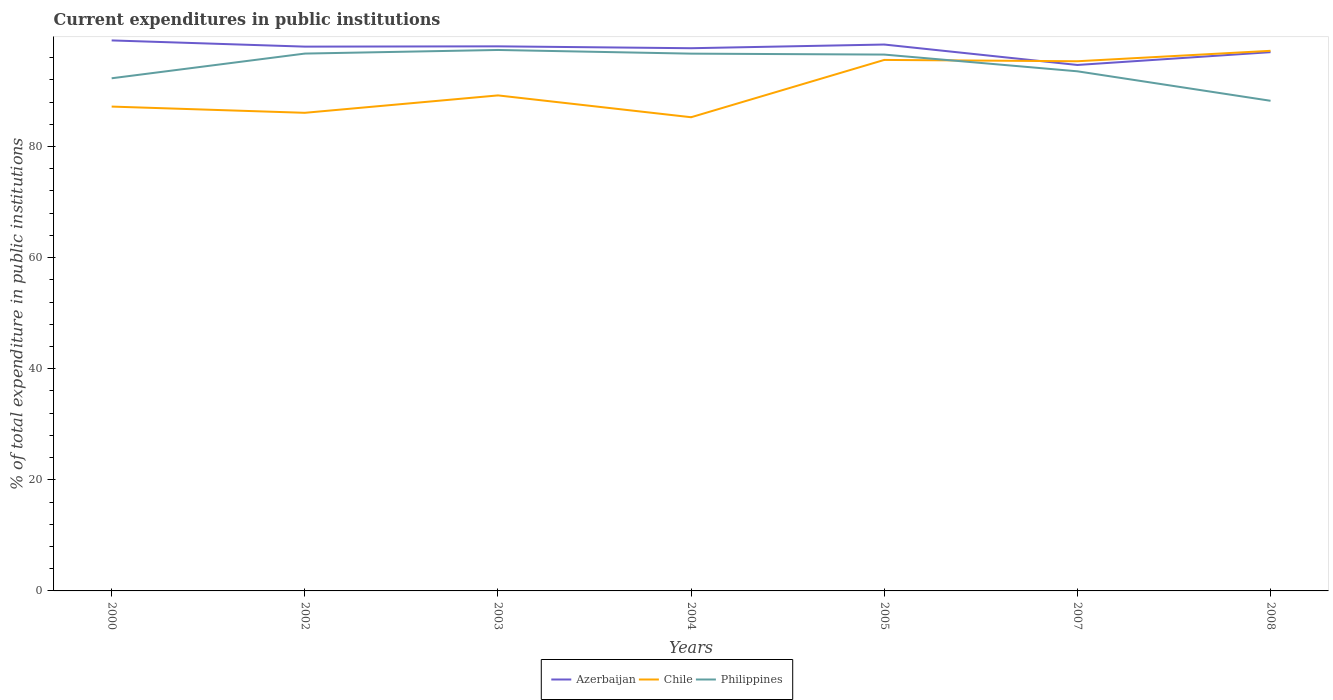Is the number of lines equal to the number of legend labels?
Provide a short and direct response. Yes. Across all years, what is the maximum current expenditures in public institutions in Philippines?
Keep it short and to the point. 88.23. In which year was the current expenditures in public institutions in Azerbaijan maximum?
Give a very brief answer. 2007. What is the total current expenditures in public institutions in Azerbaijan in the graph?
Keep it short and to the point. 1.41. What is the difference between the highest and the second highest current expenditures in public institutions in Azerbaijan?
Offer a very short reply. 4.42. Is the current expenditures in public institutions in Azerbaijan strictly greater than the current expenditures in public institutions in Chile over the years?
Your answer should be very brief. No. How many lines are there?
Keep it short and to the point. 3. What is the difference between two consecutive major ticks on the Y-axis?
Provide a succinct answer. 20. Are the values on the major ticks of Y-axis written in scientific E-notation?
Ensure brevity in your answer.  No. Does the graph contain grids?
Offer a terse response. No. Where does the legend appear in the graph?
Provide a short and direct response. Bottom center. How are the legend labels stacked?
Offer a very short reply. Horizontal. What is the title of the graph?
Your response must be concise. Current expenditures in public institutions. What is the label or title of the Y-axis?
Your response must be concise. % of total expenditure in public institutions. What is the % of total expenditure in public institutions in Azerbaijan in 2000?
Provide a short and direct response. 99.1. What is the % of total expenditure in public institutions of Chile in 2000?
Ensure brevity in your answer.  87.19. What is the % of total expenditure in public institutions of Philippines in 2000?
Provide a short and direct response. 92.28. What is the % of total expenditure in public institutions of Azerbaijan in 2002?
Offer a very short reply. 97.98. What is the % of total expenditure in public institutions in Chile in 2002?
Keep it short and to the point. 86.07. What is the % of total expenditure in public institutions in Philippines in 2002?
Offer a terse response. 96.73. What is the % of total expenditure in public institutions of Azerbaijan in 2003?
Provide a short and direct response. 98.03. What is the % of total expenditure in public institutions of Chile in 2003?
Give a very brief answer. 89.2. What is the % of total expenditure in public institutions of Philippines in 2003?
Your answer should be compact. 97.38. What is the % of total expenditure in public institutions of Azerbaijan in 2004?
Make the answer very short. 97.7. What is the % of total expenditure in public institutions in Chile in 2004?
Provide a short and direct response. 85.27. What is the % of total expenditure in public institutions of Philippines in 2004?
Provide a short and direct response. 96.72. What is the % of total expenditure in public institutions in Azerbaijan in 2005?
Ensure brevity in your answer.  98.36. What is the % of total expenditure in public institutions of Chile in 2005?
Give a very brief answer. 95.59. What is the % of total expenditure in public institutions in Philippines in 2005?
Offer a very short reply. 96.55. What is the % of total expenditure in public institutions in Azerbaijan in 2007?
Your response must be concise. 94.68. What is the % of total expenditure in public institutions of Chile in 2007?
Provide a succinct answer. 95.35. What is the % of total expenditure in public institutions of Philippines in 2007?
Provide a succinct answer. 93.54. What is the % of total expenditure in public institutions in Azerbaijan in 2008?
Offer a very short reply. 96.99. What is the % of total expenditure in public institutions in Chile in 2008?
Provide a succinct answer. 97.23. What is the % of total expenditure in public institutions in Philippines in 2008?
Your answer should be very brief. 88.23. Across all years, what is the maximum % of total expenditure in public institutions in Azerbaijan?
Give a very brief answer. 99.1. Across all years, what is the maximum % of total expenditure in public institutions of Chile?
Your answer should be compact. 97.23. Across all years, what is the maximum % of total expenditure in public institutions of Philippines?
Keep it short and to the point. 97.38. Across all years, what is the minimum % of total expenditure in public institutions of Azerbaijan?
Make the answer very short. 94.68. Across all years, what is the minimum % of total expenditure in public institutions in Chile?
Your answer should be very brief. 85.27. Across all years, what is the minimum % of total expenditure in public institutions of Philippines?
Your answer should be very brief. 88.23. What is the total % of total expenditure in public institutions of Azerbaijan in the graph?
Offer a terse response. 682.84. What is the total % of total expenditure in public institutions of Chile in the graph?
Provide a short and direct response. 635.9. What is the total % of total expenditure in public institutions of Philippines in the graph?
Provide a succinct answer. 661.44. What is the difference between the % of total expenditure in public institutions in Azerbaijan in 2000 and that in 2002?
Your answer should be very brief. 1.12. What is the difference between the % of total expenditure in public institutions of Chile in 2000 and that in 2002?
Your answer should be very brief. 1.12. What is the difference between the % of total expenditure in public institutions of Philippines in 2000 and that in 2002?
Your answer should be very brief. -4.45. What is the difference between the % of total expenditure in public institutions in Azerbaijan in 2000 and that in 2003?
Offer a terse response. 1.07. What is the difference between the % of total expenditure in public institutions of Chile in 2000 and that in 2003?
Your answer should be compact. -2.01. What is the difference between the % of total expenditure in public institutions in Philippines in 2000 and that in 2003?
Provide a succinct answer. -5.1. What is the difference between the % of total expenditure in public institutions in Azerbaijan in 2000 and that in 2004?
Provide a short and direct response. 1.41. What is the difference between the % of total expenditure in public institutions of Chile in 2000 and that in 2004?
Offer a terse response. 1.92. What is the difference between the % of total expenditure in public institutions in Philippines in 2000 and that in 2004?
Ensure brevity in your answer.  -4.44. What is the difference between the % of total expenditure in public institutions of Azerbaijan in 2000 and that in 2005?
Provide a short and direct response. 0.74. What is the difference between the % of total expenditure in public institutions in Chile in 2000 and that in 2005?
Your answer should be compact. -8.4. What is the difference between the % of total expenditure in public institutions in Philippines in 2000 and that in 2005?
Provide a succinct answer. -4.27. What is the difference between the % of total expenditure in public institutions in Azerbaijan in 2000 and that in 2007?
Provide a succinct answer. 4.42. What is the difference between the % of total expenditure in public institutions in Chile in 2000 and that in 2007?
Your answer should be very brief. -8.16. What is the difference between the % of total expenditure in public institutions of Philippines in 2000 and that in 2007?
Ensure brevity in your answer.  -1.26. What is the difference between the % of total expenditure in public institutions of Azerbaijan in 2000 and that in 2008?
Provide a succinct answer. 2.11. What is the difference between the % of total expenditure in public institutions of Chile in 2000 and that in 2008?
Your answer should be compact. -10.04. What is the difference between the % of total expenditure in public institutions in Philippines in 2000 and that in 2008?
Offer a terse response. 4.05. What is the difference between the % of total expenditure in public institutions of Azerbaijan in 2002 and that in 2003?
Your answer should be compact. -0.05. What is the difference between the % of total expenditure in public institutions in Chile in 2002 and that in 2003?
Give a very brief answer. -3.13. What is the difference between the % of total expenditure in public institutions of Philippines in 2002 and that in 2003?
Ensure brevity in your answer.  -0.65. What is the difference between the % of total expenditure in public institutions of Azerbaijan in 2002 and that in 2004?
Your answer should be compact. 0.29. What is the difference between the % of total expenditure in public institutions in Chile in 2002 and that in 2004?
Keep it short and to the point. 0.8. What is the difference between the % of total expenditure in public institutions in Philippines in 2002 and that in 2004?
Provide a succinct answer. 0.01. What is the difference between the % of total expenditure in public institutions in Azerbaijan in 2002 and that in 2005?
Provide a short and direct response. -0.38. What is the difference between the % of total expenditure in public institutions of Chile in 2002 and that in 2005?
Your answer should be very brief. -9.52. What is the difference between the % of total expenditure in public institutions of Philippines in 2002 and that in 2005?
Your answer should be very brief. 0.18. What is the difference between the % of total expenditure in public institutions in Azerbaijan in 2002 and that in 2007?
Provide a short and direct response. 3.3. What is the difference between the % of total expenditure in public institutions in Chile in 2002 and that in 2007?
Keep it short and to the point. -9.28. What is the difference between the % of total expenditure in public institutions of Philippines in 2002 and that in 2007?
Provide a succinct answer. 3.19. What is the difference between the % of total expenditure in public institutions in Chile in 2002 and that in 2008?
Keep it short and to the point. -11.16. What is the difference between the % of total expenditure in public institutions of Philippines in 2002 and that in 2008?
Offer a terse response. 8.5. What is the difference between the % of total expenditure in public institutions in Azerbaijan in 2003 and that in 2004?
Make the answer very short. 0.34. What is the difference between the % of total expenditure in public institutions in Chile in 2003 and that in 2004?
Your answer should be compact. 3.93. What is the difference between the % of total expenditure in public institutions in Philippines in 2003 and that in 2004?
Offer a very short reply. 0.66. What is the difference between the % of total expenditure in public institutions of Azerbaijan in 2003 and that in 2005?
Make the answer very short. -0.33. What is the difference between the % of total expenditure in public institutions of Chile in 2003 and that in 2005?
Your response must be concise. -6.39. What is the difference between the % of total expenditure in public institutions in Philippines in 2003 and that in 2005?
Make the answer very short. 0.83. What is the difference between the % of total expenditure in public institutions of Azerbaijan in 2003 and that in 2007?
Provide a succinct answer. 3.35. What is the difference between the % of total expenditure in public institutions of Chile in 2003 and that in 2007?
Offer a terse response. -6.15. What is the difference between the % of total expenditure in public institutions of Philippines in 2003 and that in 2007?
Your answer should be very brief. 3.84. What is the difference between the % of total expenditure in public institutions of Azerbaijan in 2003 and that in 2008?
Your answer should be very brief. 1.05. What is the difference between the % of total expenditure in public institutions of Chile in 2003 and that in 2008?
Your response must be concise. -8.03. What is the difference between the % of total expenditure in public institutions of Philippines in 2003 and that in 2008?
Offer a terse response. 9.15. What is the difference between the % of total expenditure in public institutions of Azerbaijan in 2004 and that in 2005?
Your response must be concise. -0.66. What is the difference between the % of total expenditure in public institutions of Chile in 2004 and that in 2005?
Your answer should be compact. -10.32. What is the difference between the % of total expenditure in public institutions in Philippines in 2004 and that in 2005?
Ensure brevity in your answer.  0.17. What is the difference between the % of total expenditure in public institutions in Azerbaijan in 2004 and that in 2007?
Your response must be concise. 3.02. What is the difference between the % of total expenditure in public institutions of Chile in 2004 and that in 2007?
Offer a terse response. -10.08. What is the difference between the % of total expenditure in public institutions of Philippines in 2004 and that in 2007?
Ensure brevity in your answer.  3.18. What is the difference between the % of total expenditure in public institutions of Azerbaijan in 2004 and that in 2008?
Provide a short and direct response. 0.71. What is the difference between the % of total expenditure in public institutions of Chile in 2004 and that in 2008?
Make the answer very short. -11.96. What is the difference between the % of total expenditure in public institutions in Philippines in 2004 and that in 2008?
Provide a short and direct response. 8.49. What is the difference between the % of total expenditure in public institutions of Azerbaijan in 2005 and that in 2007?
Your answer should be very brief. 3.68. What is the difference between the % of total expenditure in public institutions in Chile in 2005 and that in 2007?
Provide a succinct answer. 0.24. What is the difference between the % of total expenditure in public institutions of Philippines in 2005 and that in 2007?
Your response must be concise. 3.01. What is the difference between the % of total expenditure in public institutions of Azerbaijan in 2005 and that in 2008?
Make the answer very short. 1.37. What is the difference between the % of total expenditure in public institutions of Chile in 2005 and that in 2008?
Keep it short and to the point. -1.64. What is the difference between the % of total expenditure in public institutions of Philippines in 2005 and that in 2008?
Make the answer very short. 8.32. What is the difference between the % of total expenditure in public institutions of Azerbaijan in 2007 and that in 2008?
Offer a very short reply. -2.31. What is the difference between the % of total expenditure in public institutions in Chile in 2007 and that in 2008?
Your answer should be compact. -1.88. What is the difference between the % of total expenditure in public institutions in Philippines in 2007 and that in 2008?
Provide a succinct answer. 5.31. What is the difference between the % of total expenditure in public institutions of Azerbaijan in 2000 and the % of total expenditure in public institutions of Chile in 2002?
Your response must be concise. 13.03. What is the difference between the % of total expenditure in public institutions in Azerbaijan in 2000 and the % of total expenditure in public institutions in Philippines in 2002?
Provide a succinct answer. 2.37. What is the difference between the % of total expenditure in public institutions of Chile in 2000 and the % of total expenditure in public institutions of Philippines in 2002?
Provide a succinct answer. -9.54. What is the difference between the % of total expenditure in public institutions in Azerbaijan in 2000 and the % of total expenditure in public institutions in Chile in 2003?
Your response must be concise. 9.9. What is the difference between the % of total expenditure in public institutions in Azerbaijan in 2000 and the % of total expenditure in public institutions in Philippines in 2003?
Make the answer very short. 1.72. What is the difference between the % of total expenditure in public institutions of Chile in 2000 and the % of total expenditure in public institutions of Philippines in 2003?
Provide a succinct answer. -10.19. What is the difference between the % of total expenditure in public institutions of Azerbaijan in 2000 and the % of total expenditure in public institutions of Chile in 2004?
Give a very brief answer. 13.83. What is the difference between the % of total expenditure in public institutions of Azerbaijan in 2000 and the % of total expenditure in public institutions of Philippines in 2004?
Give a very brief answer. 2.38. What is the difference between the % of total expenditure in public institutions of Chile in 2000 and the % of total expenditure in public institutions of Philippines in 2004?
Give a very brief answer. -9.53. What is the difference between the % of total expenditure in public institutions in Azerbaijan in 2000 and the % of total expenditure in public institutions in Chile in 2005?
Your answer should be very brief. 3.51. What is the difference between the % of total expenditure in public institutions in Azerbaijan in 2000 and the % of total expenditure in public institutions in Philippines in 2005?
Keep it short and to the point. 2.55. What is the difference between the % of total expenditure in public institutions of Chile in 2000 and the % of total expenditure in public institutions of Philippines in 2005?
Offer a very short reply. -9.36. What is the difference between the % of total expenditure in public institutions in Azerbaijan in 2000 and the % of total expenditure in public institutions in Chile in 2007?
Give a very brief answer. 3.75. What is the difference between the % of total expenditure in public institutions in Azerbaijan in 2000 and the % of total expenditure in public institutions in Philippines in 2007?
Your response must be concise. 5.56. What is the difference between the % of total expenditure in public institutions in Chile in 2000 and the % of total expenditure in public institutions in Philippines in 2007?
Offer a very short reply. -6.35. What is the difference between the % of total expenditure in public institutions in Azerbaijan in 2000 and the % of total expenditure in public institutions in Chile in 2008?
Your answer should be compact. 1.87. What is the difference between the % of total expenditure in public institutions of Azerbaijan in 2000 and the % of total expenditure in public institutions of Philippines in 2008?
Offer a very short reply. 10.87. What is the difference between the % of total expenditure in public institutions in Chile in 2000 and the % of total expenditure in public institutions in Philippines in 2008?
Provide a short and direct response. -1.04. What is the difference between the % of total expenditure in public institutions in Azerbaijan in 2002 and the % of total expenditure in public institutions in Chile in 2003?
Provide a short and direct response. 8.78. What is the difference between the % of total expenditure in public institutions in Azerbaijan in 2002 and the % of total expenditure in public institutions in Philippines in 2003?
Give a very brief answer. 0.6. What is the difference between the % of total expenditure in public institutions in Chile in 2002 and the % of total expenditure in public institutions in Philippines in 2003?
Ensure brevity in your answer.  -11.31. What is the difference between the % of total expenditure in public institutions in Azerbaijan in 2002 and the % of total expenditure in public institutions in Chile in 2004?
Your answer should be compact. 12.71. What is the difference between the % of total expenditure in public institutions in Azerbaijan in 2002 and the % of total expenditure in public institutions in Philippines in 2004?
Keep it short and to the point. 1.26. What is the difference between the % of total expenditure in public institutions in Chile in 2002 and the % of total expenditure in public institutions in Philippines in 2004?
Ensure brevity in your answer.  -10.65. What is the difference between the % of total expenditure in public institutions in Azerbaijan in 2002 and the % of total expenditure in public institutions in Chile in 2005?
Offer a terse response. 2.39. What is the difference between the % of total expenditure in public institutions in Azerbaijan in 2002 and the % of total expenditure in public institutions in Philippines in 2005?
Offer a terse response. 1.43. What is the difference between the % of total expenditure in public institutions of Chile in 2002 and the % of total expenditure in public institutions of Philippines in 2005?
Ensure brevity in your answer.  -10.48. What is the difference between the % of total expenditure in public institutions in Azerbaijan in 2002 and the % of total expenditure in public institutions in Chile in 2007?
Provide a succinct answer. 2.63. What is the difference between the % of total expenditure in public institutions in Azerbaijan in 2002 and the % of total expenditure in public institutions in Philippines in 2007?
Offer a very short reply. 4.44. What is the difference between the % of total expenditure in public institutions in Chile in 2002 and the % of total expenditure in public institutions in Philippines in 2007?
Ensure brevity in your answer.  -7.47. What is the difference between the % of total expenditure in public institutions in Azerbaijan in 2002 and the % of total expenditure in public institutions in Chile in 2008?
Offer a very short reply. 0.75. What is the difference between the % of total expenditure in public institutions in Azerbaijan in 2002 and the % of total expenditure in public institutions in Philippines in 2008?
Make the answer very short. 9.75. What is the difference between the % of total expenditure in public institutions of Chile in 2002 and the % of total expenditure in public institutions of Philippines in 2008?
Provide a short and direct response. -2.16. What is the difference between the % of total expenditure in public institutions in Azerbaijan in 2003 and the % of total expenditure in public institutions in Chile in 2004?
Ensure brevity in your answer.  12.76. What is the difference between the % of total expenditure in public institutions in Azerbaijan in 2003 and the % of total expenditure in public institutions in Philippines in 2004?
Your answer should be compact. 1.31. What is the difference between the % of total expenditure in public institutions in Chile in 2003 and the % of total expenditure in public institutions in Philippines in 2004?
Make the answer very short. -7.52. What is the difference between the % of total expenditure in public institutions in Azerbaijan in 2003 and the % of total expenditure in public institutions in Chile in 2005?
Your answer should be very brief. 2.44. What is the difference between the % of total expenditure in public institutions in Azerbaijan in 2003 and the % of total expenditure in public institutions in Philippines in 2005?
Your response must be concise. 1.48. What is the difference between the % of total expenditure in public institutions of Chile in 2003 and the % of total expenditure in public institutions of Philippines in 2005?
Ensure brevity in your answer.  -7.35. What is the difference between the % of total expenditure in public institutions of Azerbaijan in 2003 and the % of total expenditure in public institutions of Chile in 2007?
Ensure brevity in your answer.  2.68. What is the difference between the % of total expenditure in public institutions of Azerbaijan in 2003 and the % of total expenditure in public institutions of Philippines in 2007?
Keep it short and to the point. 4.49. What is the difference between the % of total expenditure in public institutions of Chile in 2003 and the % of total expenditure in public institutions of Philippines in 2007?
Your response must be concise. -4.34. What is the difference between the % of total expenditure in public institutions in Azerbaijan in 2003 and the % of total expenditure in public institutions in Chile in 2008?
Make the answer very short. 0.8. What is the difference between the % of total expenditure in public institutions in Azerbaijan in 2003 and the % of total expenditure in public institutions in Philippines in 2008?
Provide a short and direct response. 9.8. What is the difference between the % of total expenditure in public institutions of Chile in 2003 and the % of total expenditure in public institutions of Philippines in 2008?
Your answer should be compact. 0.97. What is the difference between the % of total expenditure in public institutions in Azerbaijan in 2004 and the % of total expenditure in public institutions in Chile in 2005?
Give a very brief answer. 2.11. What is the difference between the % of total expenditure in public institutions of Azerbaijan in 2004 and the % of total expenditure in public institutions of Philippines in 2005?
Keep it short and to the point. 1.14. What is the difference between the % of total expenditure in public institutions of Chile in 2004 and the % of total expenditure in public institutions of Philippines in 2005?
Keep it short and to the point. -11.28. What is the difference between the % of total expenditure in public institutions of Azerbaijan in 2004 and the % of total expenditure in public institutions of Chile in 2007?
Your response must be concise. 2.35. What is the difference between the % of total expenditure in public institutions in Azerbaijan in 2004 and the % of total expenditure in public institutions in Philippines in 2007?
Provide a short and direct response. 4.16. What is the difference between the % of total expenditure in public institutions in Chile in 2004 and the % of total expenditure in public institutions in Philippines in 2007?
Keep it short and to the point. -8.27. What is the difference between the % of total expenditure in public institutions in Azerbaijan in 2004 and the % of total expenditure in public institutions in Chile in 2008?
Your answer should be compact. 0.47. What is the difference between the % of total expenditure in public institutions in Azerbaijan in 2004 and the % of total expenditure in public institutions in Philippines in 2008?
Make the answer very short. 9.46. What is the difference between the % of total expenditure in public institutions in Chile in 2004 and the % of total expenditure in public institutions in Philippines in 2008?
Your response must be concise. -2.96. What is the difference between the % of total expenditure in public institutions of Azerbaijan in 2005 and the % of total expenditure in public institutions of Chile in 2007?
Provide a short and direct response. 3.01. What is the difference between the % of total expenditure in public institutions of Azerbaijan in 2005 and the % of total expenditure in public institutions of Philippines in 2007?
Provide a short and direct response. 4.82. What is the difference between the % of total expenditure in public institutions of Chile in 2005 and the % of total expenditure in public institutions of Philippines in 2007?
Give a very brief answer. 2.05. What is the difference between the % of total expenditure in public institutions in Azerbaijan in 2005 and the % of total expenditure in public institutions in Chile in 2008?
Offer a terse response. 1.13. What is the difference between the % of total expenditure in public institutions of Azerbaijan in 2005 and the % of total expenditure in public institutions of Philippines in 2008?
Provide a short and direct response. 10.13. What is the difference between the % of total expenditure in public institutions in Chile in 2005 and the % of total expenditure in public institutions in Philippines in 2008?
Your answer should be very brief. 7.36. What is the difference between the % of total expenditure in public institutions of Azerbaijan in 2007 and the % of total expenditure in public institutions of Chile in 2008?
Give a very brief answer. -2.55. What is the difference between the % of total expenditure in public institutions in Azerbaijan in 2007 and the % of total expenditure in public institutions in Philippines in 2008?
Ensure brevity in your answer.  6.45. What is the difference between the % of total expenditure in public institutions of Chile in 2007 and the % of total expenditure in public institutions of Philippines in 2008?
Provide a succinct answer. 7.12. What is the average % of total expenditure in public institutions in Azerbaijan per year?
Provide a succinct answer. 97.55. What is the average % of total expenditure in public institutions in Chile per year?
Offer a very short reply. 90.84. What is the average % of total expenditure in public institutions of Philippines per year?
Make the answer very short. 94.49. In the year 2000, what is the difference between the % of total expenditure in public institutions in Azerbaijan and % of total expenditure in public institutions in Chile?
Make the answer very short. 11.91. In the year 2000, what is the difference between the % of total expenditure in public institutions of Azerbaijan and % of total expenditure in public institutions of Philippines?
Offer a terse response. 6.82. In the year 2000, what is the difference between the % of total expenditure in public institutions of Chile and % of total expenditure in public institutions of Philippines?
Ensure brevity in your answer.  -5.1. In the year 2002, what is the difference between the % of total expenditure in public institutions of Azerbaijan and % of total expenditure in public institutions of Chile?
Your response must be concise. 11.91. In the year 2002, what is the difference between the % of total expenditure in public institutions in Azerbaijan and % of total expenditure in public institutions in Philippines?
Ensure brevity in your answer.  1.25. In the year 2002, what is the difference between the % of total expenditure in public institutions in Chile and % of total expenditure in public institutions in Philippines?
Offer a terse response. -10.66. In the year 2003, what is the difference between the % of total expenditure in public institutions in Azerbaijan and % of total expenditure in public institutions in Chile?
Provide a short and direct response. 8.83. In the year 2003, what is the difference between the % of total expenditure in public institutions of Azerbaijan and % of total expenditure in public institutions of Philippines?
Provide a succinct answer. 0.65. In the year 2003, what is the difference between the % of total expenditure in public institutions of Chile and % of total expenditure in public institutions of Philippines?
Offer a very short reply. -8.18. In the year 2004, what is the difference between the % of total expenditure in public institutions of Azerbaijan and % of total expenditure in public institutions of Chile?
Provide a succinct answer. 12.42. In the year 2004, what is the difference between the % of total expenditure in public institutions of Azerbaijan and % of total expenditure in public institutions of Philippines?
Make the answer very short. 0.98. In the year 2004, what is the difference between the % of total expenditure in public institutions in Chile and % of total expenditure in public institutions in Philippines?
Offer a very short reply. -11.45. In the year 2005, what is the difference between the % of total expenditure in public institutions in Azerbaijan and % of total expenditure in public institutions in Chile?
Your answer should be very brief. 2.77. In the year 2005, what is the difference between the % of total expenditure in public institutions in Azerbaijan and % of total expenditure in public institutions in Philippines?
Give a very brief answer. 1.81. In the year 2005, what is the difference between the % of total expenditure in public institutions of Chile and % of total expenditure in public institutions of Philippines?
Keep it short and to the point. -0.96. In the year 2007, what is the difference between the % of total expenditure in public institutions of Azerbaijan and % of total expenditure in public institutions of Chile?
Provide a short and direct response. -0.67. In the year 2007, what is the difference between the % of total expenditure in public institutions of Azerbaijan and % of total expenditure in public institutions of Philippines?
Provide a short and direct response. 1.14. In the year 2007, what is the difference between the % of total expenditure in public institutions in Chile and % of total expenditure in public institutions in Philippines?
Offer a terse response. 1.81. In the year 2008, what is the difference between the % of total expenditure in public institutions in Azerbaijan and % of total expenditure in public institutions in Chile?
Provide a short and direct response. -0.24. In the year 2008, what is the difference between the % of total expenditure in public institutions in Azerbaijan and % of total expenditure in public institutions in Philippines?
Provide a succinct answer. 8.76. In the year 2008, what is the difference between the % of total expenditure in public institutions of Chile and % of total expenditure in public institutions of Philippines?
Keep it short and to the point. 9. What is the ratio of the % of total expenditure in public institutions of Azerbaijan in 2000 to that in 2002?
Your answer should be very brief. 1.01. What is the ratio of the % of total expenditure in public institutions of Chile in 2000 to that in 2002?
Keep it short and to the point. 1.01. What is the ratio of the % of total expenditure in public institutions in Philippines in 2000 to that in 2002?
Offer a terse response. 0.95. What is the ratio of the % of total expenditure in public institutions in Azerbaijan in 2000 to that in 2003?
Keep it short and to the point. 1.01. What is the ratio of the % of total expenditure in public institutions in Chile in 2000 to that in 2003?
Offer a terse response. 0.98. What is the ratio of the % of total expenditure in public institutions of Philippines in 2000 to that in 2003?
Give a very brief answer. 0.95. What is the ratio of the % of total expenditure in public institutions of Azerbaijan in 2000 to that in 2004?
Offer a terse response. 1.01. What is the ratio of the % of total expenditure in public institutions of Chile in 2000 to that in 2004?
Keep it short and to the point. 1.02. What is the ratio of the % of total expenditure in public institutions of Philippines in 2000 to that in 2004?
Make the answer very short. 0.95. What is the ratio of the % of total expenditure in public institutions of Azerbaijan in 2000 to that in 2005?
Your response must be concise. 1.01. What is the ratio of the % of total expenditure in public institutions of Chile in 2000 to that in 2005?
Offer a very short reply. 0.91. What is the ratio of the % of total expenditure in public institutions of Philippines in 2000 to that in 2005?
Provide a succinct answer. 0.96. What is the ratio of the % of total expenditure in public institutions in Azerbaijan in 2000 to that in 2007?
Ensure brevity in your answer.  1.05. What is the ratio of the % of total expenditure in public institutions of Chile in 2000 to that in 2007?
Offer a terse response. 0.91. What is the ratio of the % of total expenditure in public institutions in Philippines in 2000 to that in 2007?
Make the answer very short. 0.99. What is the ratio of the % of total expenditure in public institutions of Azerbaijan in 2000 to that in 2008?
Provide a succinct answer. 1.02. What is the ratio of the % of total expenditure in public institutions in Chile in 2000 to that in 2008?
Give a very brief answer. 0.9. What is the ratio of the % of total expenditure in public institutions of Philippines in 2000 to that in 2008?
Provide a succinct answer. 1.05. What is the ratio of the % of total expenditure in public institutions in Azerbaijan in 2002 to that in 2003?
Offer a terse response. 1. What is the ratio of the % of total expenditure in public institutions in Chile in 2002 to that in 2003?
Your answer should be compact. 0.96. What is the ratio of the % of total expenditure in public institutions of Chile in 2002 to that in 2004?
Offer a very short reply. 1.01. What is the ratio of the % of total expenditure in public institutions of Chile in 2002 to that in 2005?
Give a very brief answer. 0.9. What is the ratio of the % of total expenditure in public institutions in Azerbaijan in 2002 to that in 2007?
Make the answer very short. 1.03. What is the ratio of the % of total expenditure in public institutions in Chile in 2002 to that in 2007?
Ensure brevity in your answer.  0.9. What is the ratio of the % of total expenditure in public institutions of Philippines in 2002 to that in 2007?
Your answer should be very brief. 1.03. What is the ratio of the % of total expenditure in public institutions of Azerbaijan in 2002 to that in 2008?
Your answer should be very brief. 1.01. What is the ratio of the % of total expenditure in public institutions in Chile in 2002 to that in 2008?
Make the answer very short. 0.89. What is the ratio of the % of total expenditure in public institutions in Philippines in 2002 to that in 2008?
Offer a very short reply. 1.1. What is the ratio of the % of total expenditure in public institutions of Chile in 2003 to that in 2004?
Offer a very short reply. 1.05. What is the ratio of the % of total expenditure in public institutions of Philippines in 2003 to that in 2004?
Your answer should be compact. 1.01. What is the ratio of the % of total expenditure in public institutions of Azerbaijan in 2003 to that in 2005?
Keep it short and to the point. 1. What is the ratio of the % of total expenditure in public institutions of Chile in 2003 to that in 2005?
Make the answer very short. 0.93. What is the ratio of the % of total expenditure in public institutions of Philippines in 2003 to that in 2005?
Ensure brevity in your answer.  1.01. What is the ratio of the % of total expenditure in public institutions in Azerbaijan in 2003 to that in 2007?
Your answer should be very brief. 1.04. What is the ratio of the % of total expenditure in public institutions of Chile in 2003 to that in 2007?
Offer a terse response. 0.94. What is the ratio of the % of total expenditure in public institutions in Philippines in 2003 to that in 2007?
Ensure brevity in your answer.  1.04. What is the ratio of the % of total expenditure in public institutions in Azerbaijan in 2003 to that in 2008?
Offer a terse response. 1.01. What is the ratio of the % of total expenditure in public institutions of Chile in 2003 to that in 2008?
Your answer should be compact. 0.92. What is the ratio of the % of total expenditure in public institutions of Philippines in 2003 to that in 2008?
Give a very brief answer. 1.1. What is the ratio of the % of total expenditure in public institutions in Chile in 2004 to that in 2005?
Your answer should be very brief. 0.89. What is the ratio of the % of total expenditure in public institutions in Philippines in 2004 to that in 2005?
Your answer should be very brief. 1. What is the ratio of the % of total expenditure in public institutions of Azerbaijan in 2004 to that in 2007?
Offer a very short reply. 1.03. What is the ratio of the % of total expenditure in public institutions in Chile in 2004 to that in 2007?
Offer a terse response. 0.89. What is the ratio of the % of total expenditure in public institutions in Philippines in 2004 to that in 2007?
Give a very brief answer. 1.03. What is the ratio of the % of total expenditure in public institutions in Azerbaijan in 2004 to that in 2008?
Keep it short and to the point. 1.01. What is the ratio of the % of total expenditure in public institutions of Chile in 2004 to that in 2008?
Provide a short and direct response. 0.88. What is the ratio of the % of total expenditure in public institutions of Philippines in 2004 to that in 2008?
Provide a short and direct response. 1.1. What is the ratio of the % of total expenditure in public institutions of Azerbaijan in 2005 to that in 2007?
Your answer should be very brief. 1.04. What is the ratio of the % of total expenditure in public institutions in Philippines in 2005 to that in 2007?
Provide a short and direct response. 1.03. What is the ratio of the % of total expenditure in public institutions in Azerbaijan in 2005 to that in 2008?
Keep it short and to the point. 1.01. What is the ratio of the % of total expenditure in public institutions of Chile in 2005 to that in 2008?
Provide a succinct answer. 0.98. What is the ratio of the % of total expenditure in public institutions of Philippines in 2005 to that in 2008?
Your answer should be very brief. 1.09. What is the ratio of the % of total expenditure in public institutions of Azerbaijan in 2007 to that in 2008?
Make the answer very short. 0.98. What is the ratio of the % of total expenditure in public institutions of Chile in 2007 to that in 2008?
Offer a terse response. 0.98. What is the ratio of the % of total expenditure in public institutions in Philippines in 2007 to that in 2008?
Offer a very short reply. 1.06. What is the difference between the highest and the second highest % of total expenditure in public institutions in Azerbaijan?
Make the answer very short. 0.74. What is the difference between the highest and the second highest % of total expenditure in public institutions in Chile?
Your response must be concise. 1.64. What is the difference between the highest and the second highest % of total expenditure in public institutions of Philippines?
Provide a succinct answer. 0.65. What is the difference between the highest and the lowest % of total expenditure in public institutions in Azerbaijan?
Your response must be concise. 4.42. What is the difference between the highest and the lowest % of total expenditure in public institutions in Chile?
Keep it short and to the point. 11.96. What is the difference between the highest and the lowest % of total expenditure in public institutions of Philippines?
Provide a short and direct response. 9.15. 